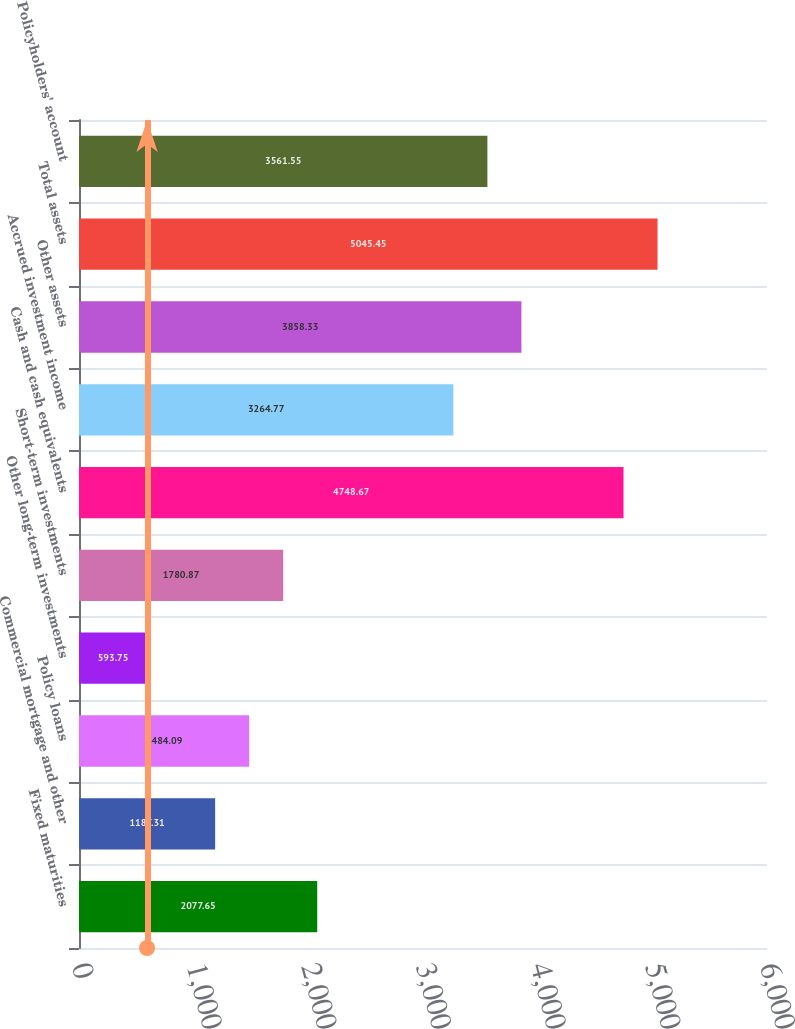Convert chart to OTSL. <chart><loc_0><loc_0><loc_500><loc_500><bar_chart><fcel>Fixed maturities<fcel>Commercial mortgage and other<fcel>Policy loans<fcel>Other long-term investments<fcel>Short-term investments<fcel>Cash and cash equivalents<fcel>Accrued investment income<fcel>Other assets<fcel>Total assets<fcel>Policyholders' account<nl><fcel>2077.65<fcel>1187.31<fcel>1484.09<fcel>593.75<fcel>1780.87<fcel>4748.67<fcel>3264.77<fcel>3858.33<fcel>5045.45<fcel>3561.55<nl></chart> 